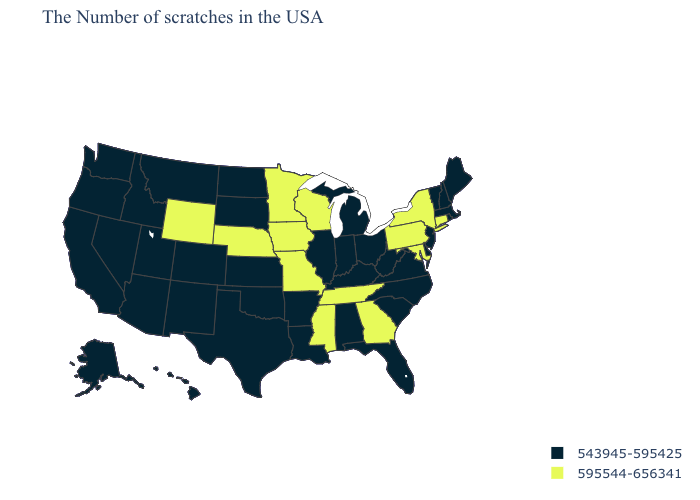Name the states that have a value in the range 595544-656341?
Short answer required. Connecticut, New York, Maryland, Pennsylvania, Georgia, Tennessee, Wisconsin, Mississippi, Missouri, Minnesota, Iowa, Nebraska, Wyoming. Name the states that have a value in the range 595544-656341?
Quick response, please. Connecticut, New York, Maryland, Pennsylvania, Georgia, Tennessee, Wisconsin, Mississippi, Missouri, Minnesota, Iowa, Nebraska, Wyoming. Which states have the lowest value in the USA?
Keep it brief. Maine, Massachusetts, Rhode Island, New Hampshire, Vermont, New Jersey, Delaware, Virginia, North Carolina, South Carolina, West Virginia, Ohio, Florida, Michigan, Kentucky, Indiana, Alabama, Illinois, Louisiana, Arkansas, Kansas, Oklahoma, Texas, South Dakota, North Dakota, Colorado, New Mexico, Utah, Montana, Arizona, Idaho, Nevada, California, Washington, Oregon, Alaska, Hawaii. What is the lowest value in states that border Idaho?
Concise answer only. 543945-595425. What is the value of New York?
Quick response, please. 595544-656341. Does Ohio have the highest value in the MidWest?
Concise answer only. No. Name the states that have a value in the range 543945-595425?
Keep it brief. Maine, Massachusetts, Rhode Island, New Hampshire, Vermont, New Jersey, Delaware, Virginia, North Carolina, South Carolina, West Virginia, Ohio, Florida, Michigan, Kentucky, Indiana, Alabama, Illinois, Louisiana, Arkansas, Kansas, Oklahoma, Texas, South Dakota, North Dakota, Colorado, New Mexico, Utah, Montana, Arizona, Idaho, Nevada, California, Washington, Oregon, Alaska, Hawaii. What is the value of Delaware?
Keep it brief. 543945-595425. Does the map have missing data?
Short answer required. No. What is the value of West Virginia?
Write a very short answer. 543945-595425. Does Minnesota have the lowest value in the USA?
Be succinct. No. What is the lowest value in the MidWest?
Answer briefly. 543945-595425. What is the lowest value in the Northeast?
Quick response, please. 543945-595425. Name the states that have a value in the range 543945-595425?
Quick response, please. Maine, Massachusetts, Rhode Island, New Hampshire, Vermont, New Jersey, Delaware, Virginia, North Carolina, South Carolina, West Virginia, Ohio, Florida, Michigan, Kentucky, Indiana, Alabama, Illinois, Louisiana, Arkansas, Kansas, Oklahoma, Texas, South Dakota, North Dakota, Colorado, New Mexico, Utah, Montana, Arizona, Idaho, Nevada, California, Washington, Oregon, Alaska, Hawaii. Which states hav the highest value in the MidWest?
Give a very brief answer. Wisconsin, Missouri, Minnesota, Iowa, Nebraska. 